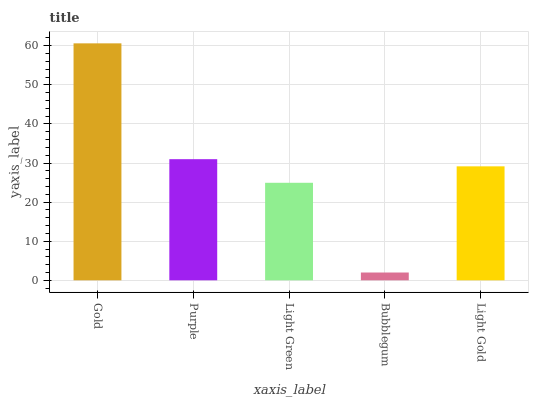Is Bubblegum the minimum?
Answer yes or no. Yes. Is Gold the maximum?
Answer yes or no. Yes. Is Purple the minimum?
Answer yes or no. No. Is Purple the maximum?
Answer yes or no. No. Is Gold greater than Purple?
Answer yes or no. Yes. Is Purple less than Gold?
Answer yes or no. Yes. Is Purple greater than Gold?
Answer yes or no. No. Is Gold less than Purple?
Answer yes or no. No. Is Light Gold the high median?
Answer yes or no. Yes. Is Light Gold the low median?
Answer yes or no. Yes. Is Gold the high median?
Answer yes or no. No. Is Gold the low median?
Answer yes or no. No. 